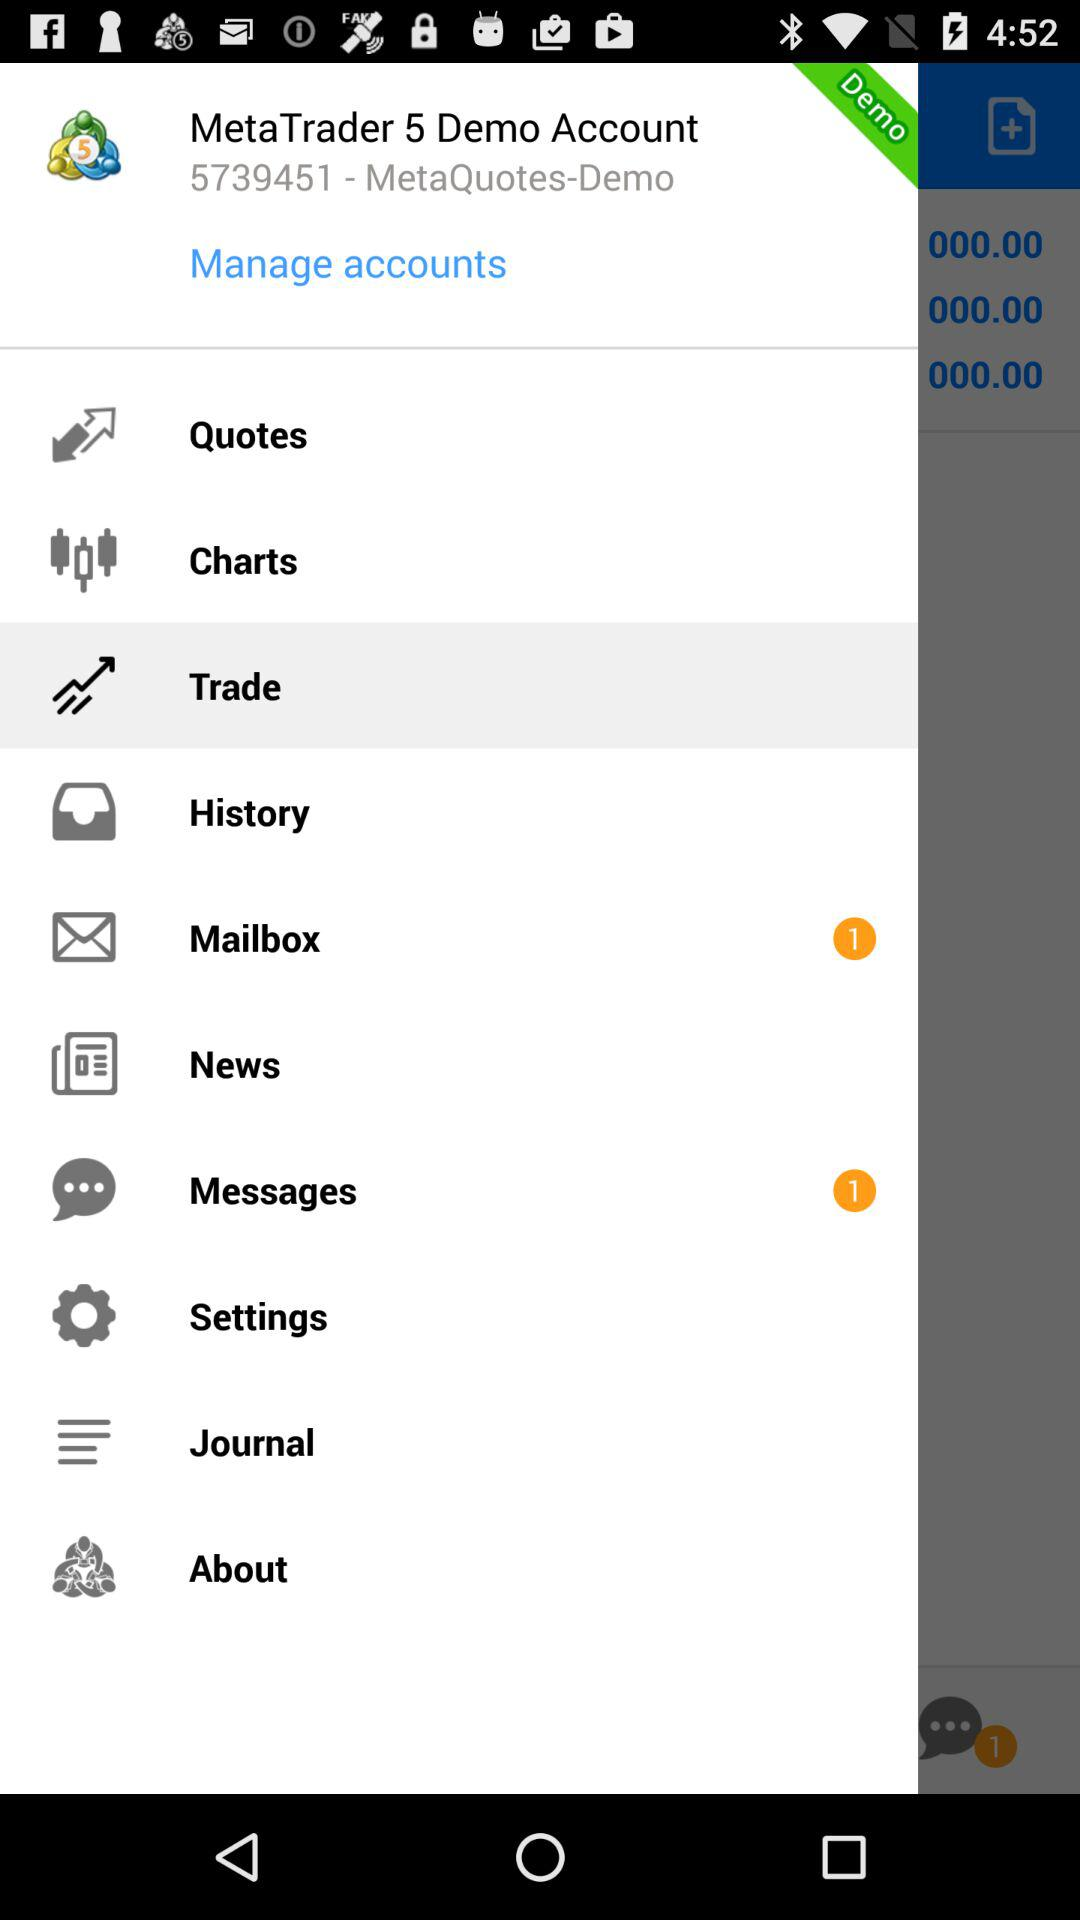What is the number of new e-mails? The number of new e-mails is 1. 